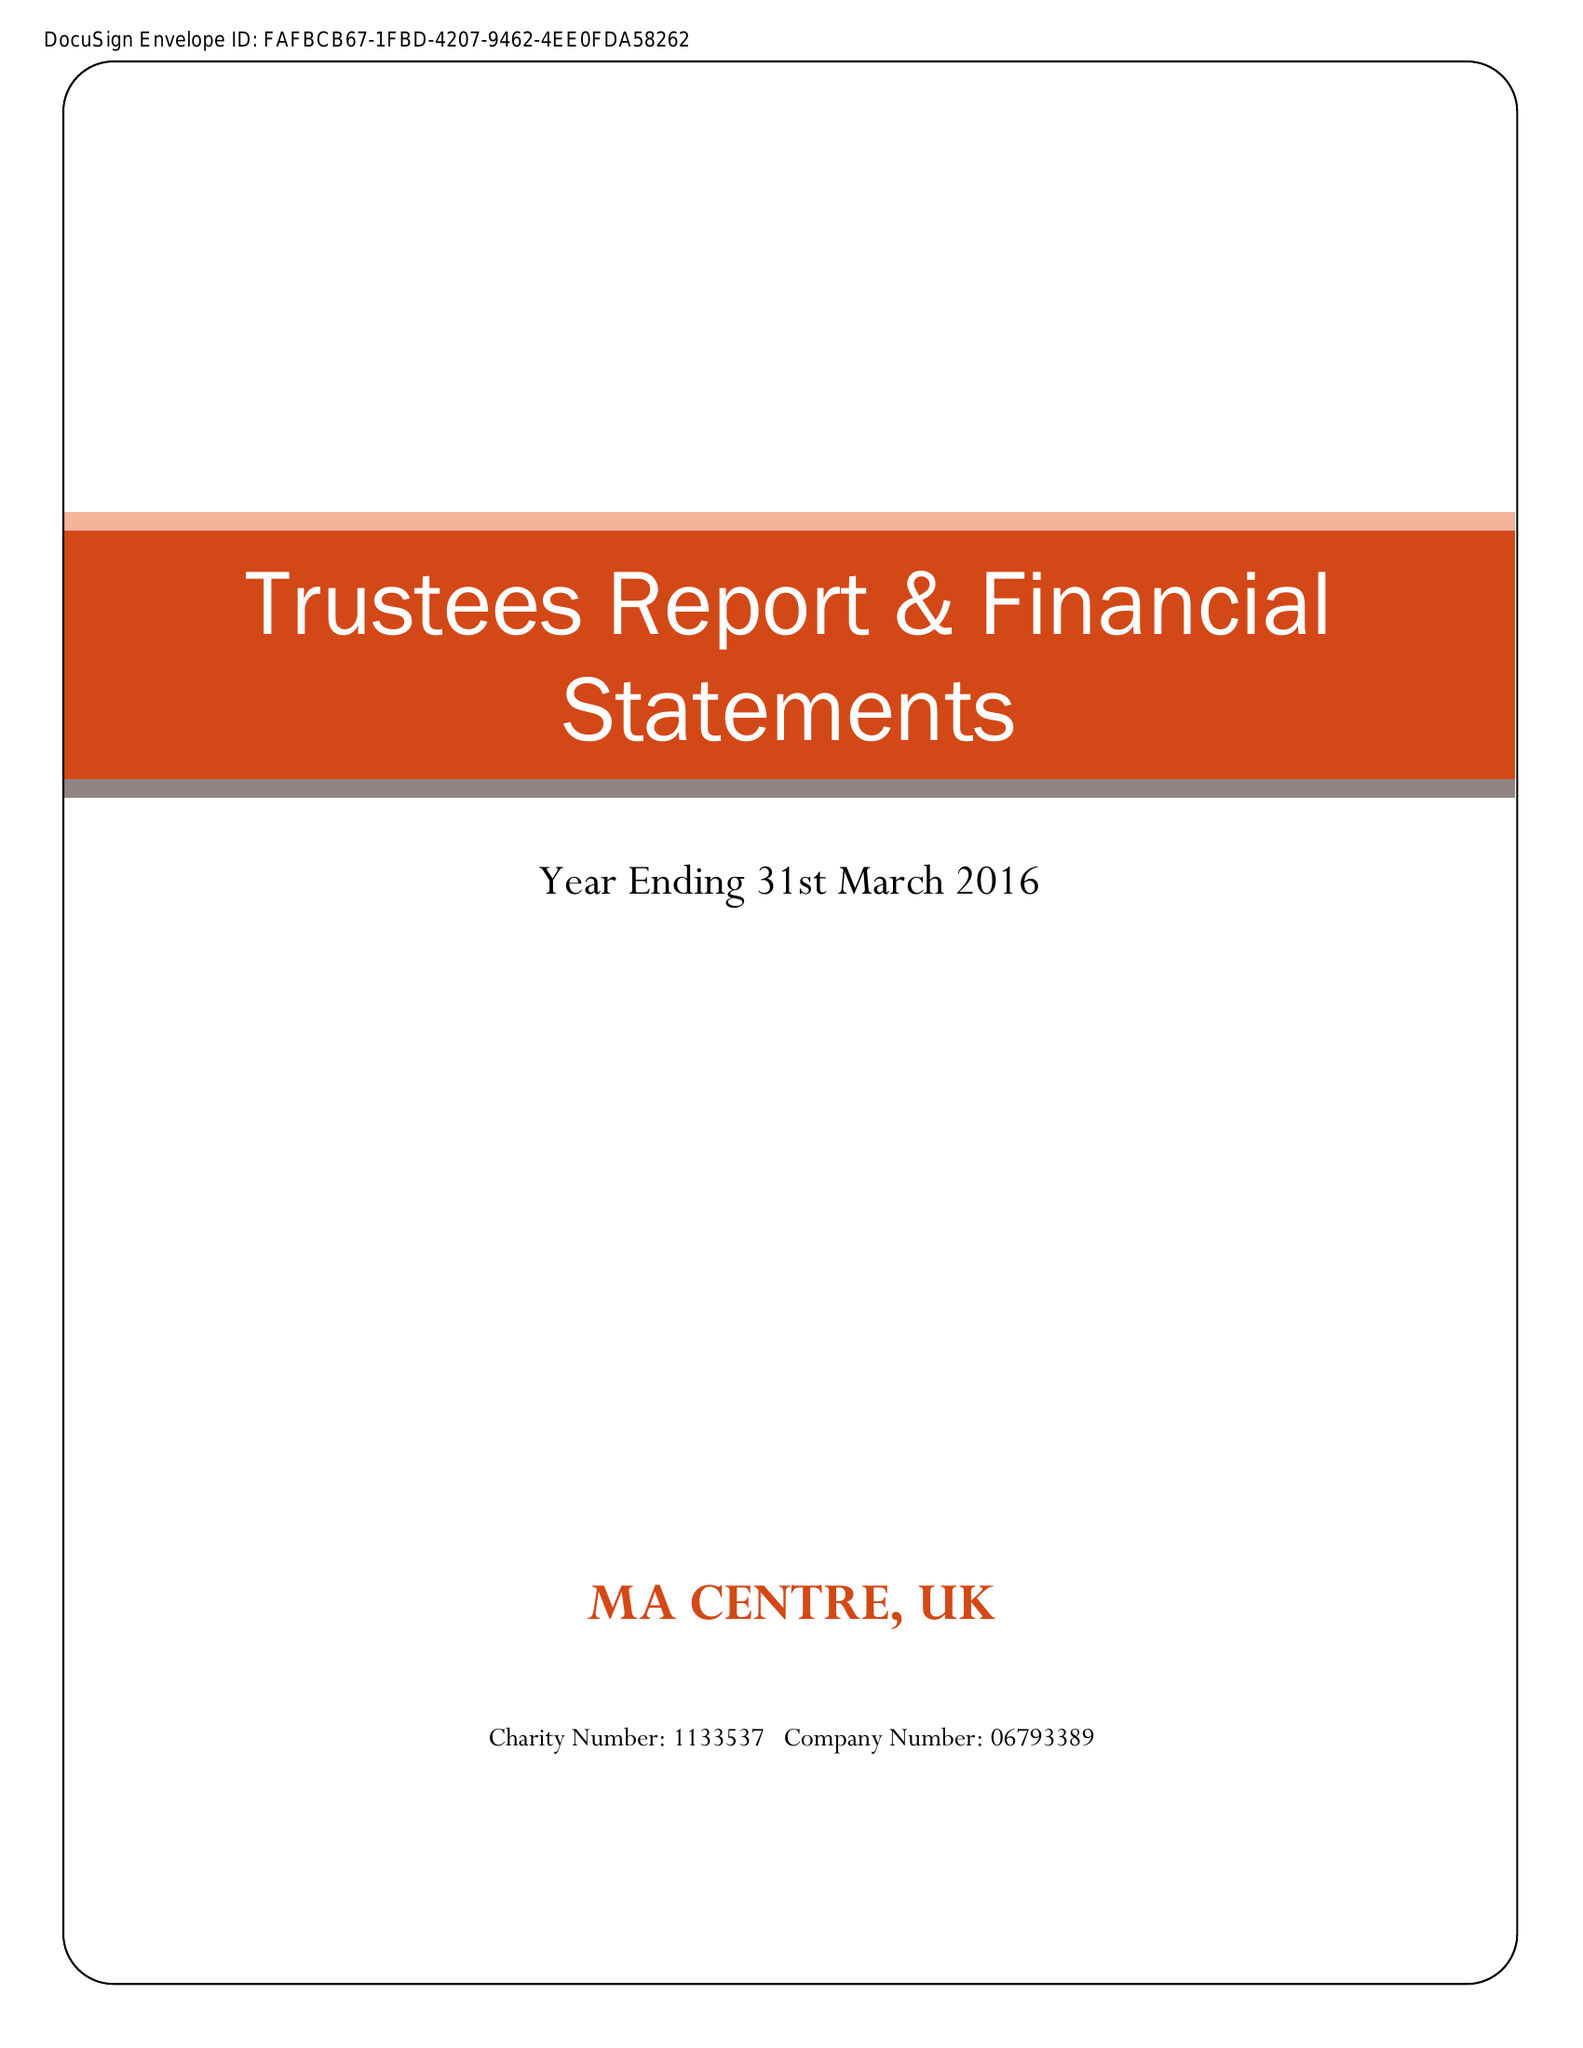What is the value for the report_date?
Answer the question using a single word or phrase. 2016-03-31 